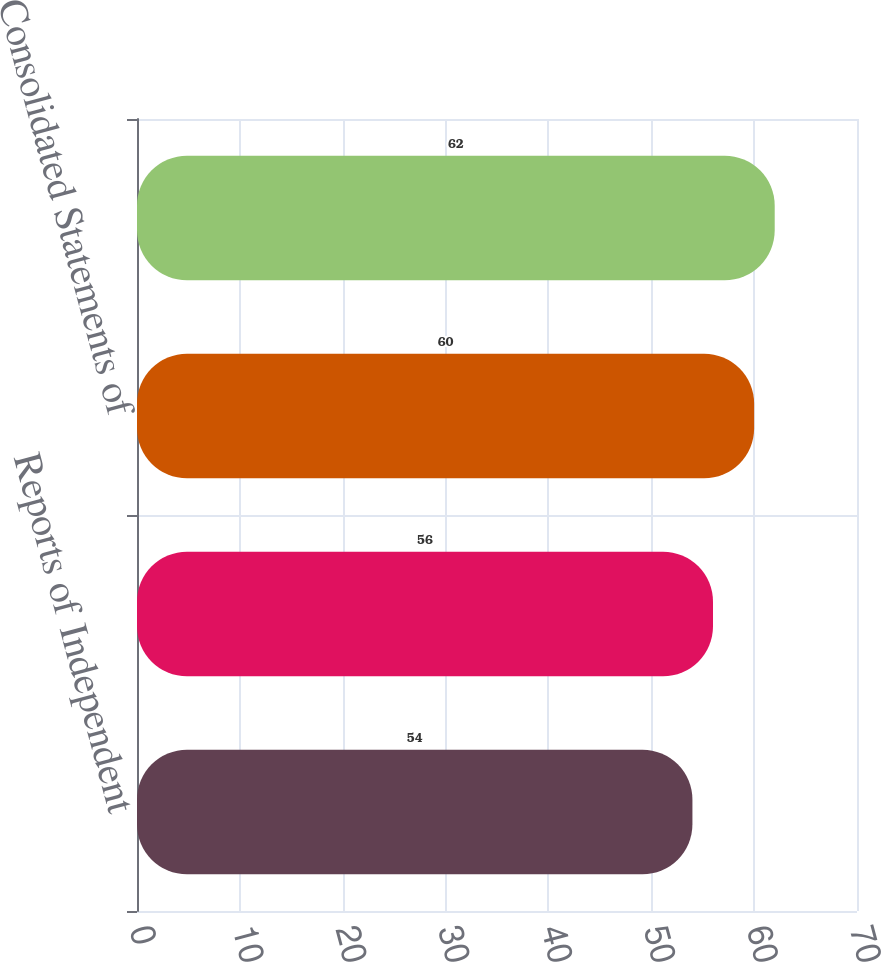<chart> <loc_0><loc_0><loc_500><loc_500><bar_chart><fcel>Reports of Independent<fcel>Consolidated Balance Sheets<fcel>Consolidated Statements of<fcel>Notes to Consolidated<nl><fcel>54<fcel>56<fcel>60<fcel>62<nl></chart> 